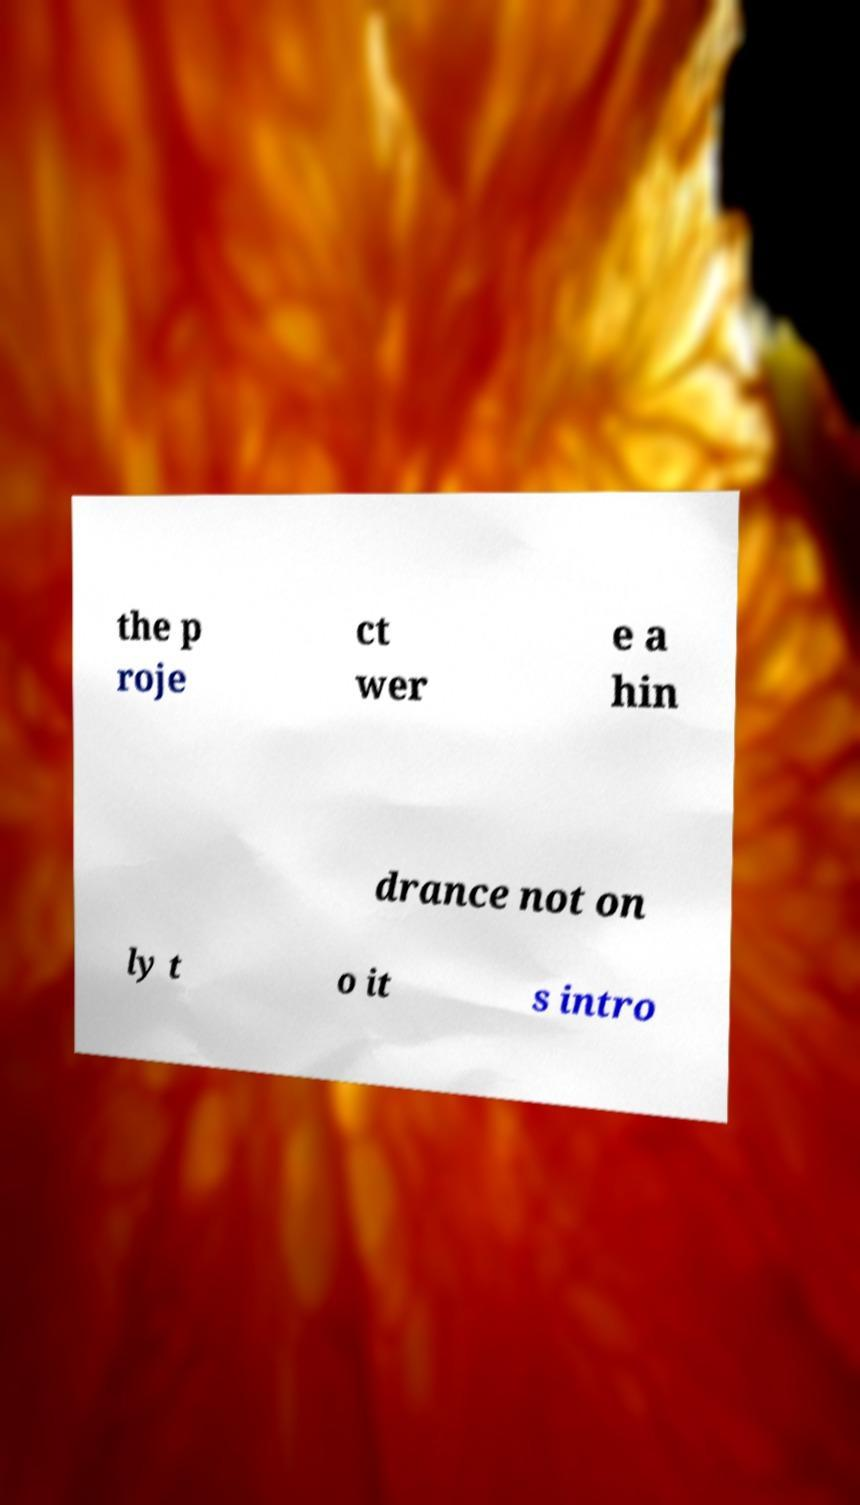There's text embedded in this image that I need extracted. Can you transcribe it verbatim? the p roje ct wer e a hin drance not on ly t o it s intro 